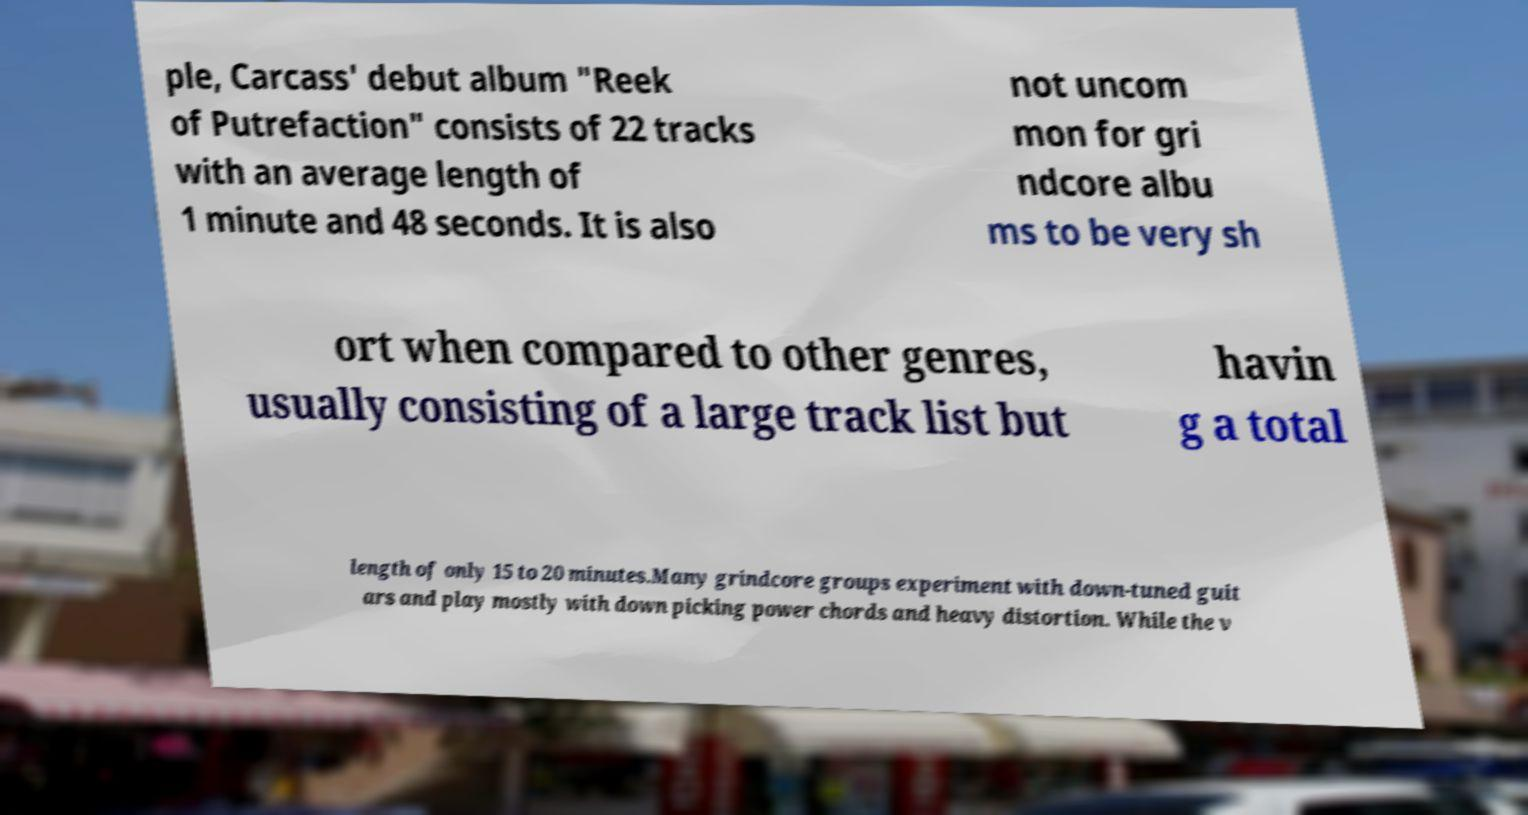Can you accurately transcribe the text from the provided image for me? ple, Carcass' debut album "Reek of Putrefaction" consists of 22 tracks with an average length of 1 minute and 48 seconds. It is also not uncom mon for gri ndcore albu ms to be very sh ort when compared to other genres, usually consisting of a large track list but havin g a total length of only 15 to 20 minutes.Many grindcore groups experiment with down-tuned guit ars and play mostly with down picking power chords and heavy distortion. While the v 